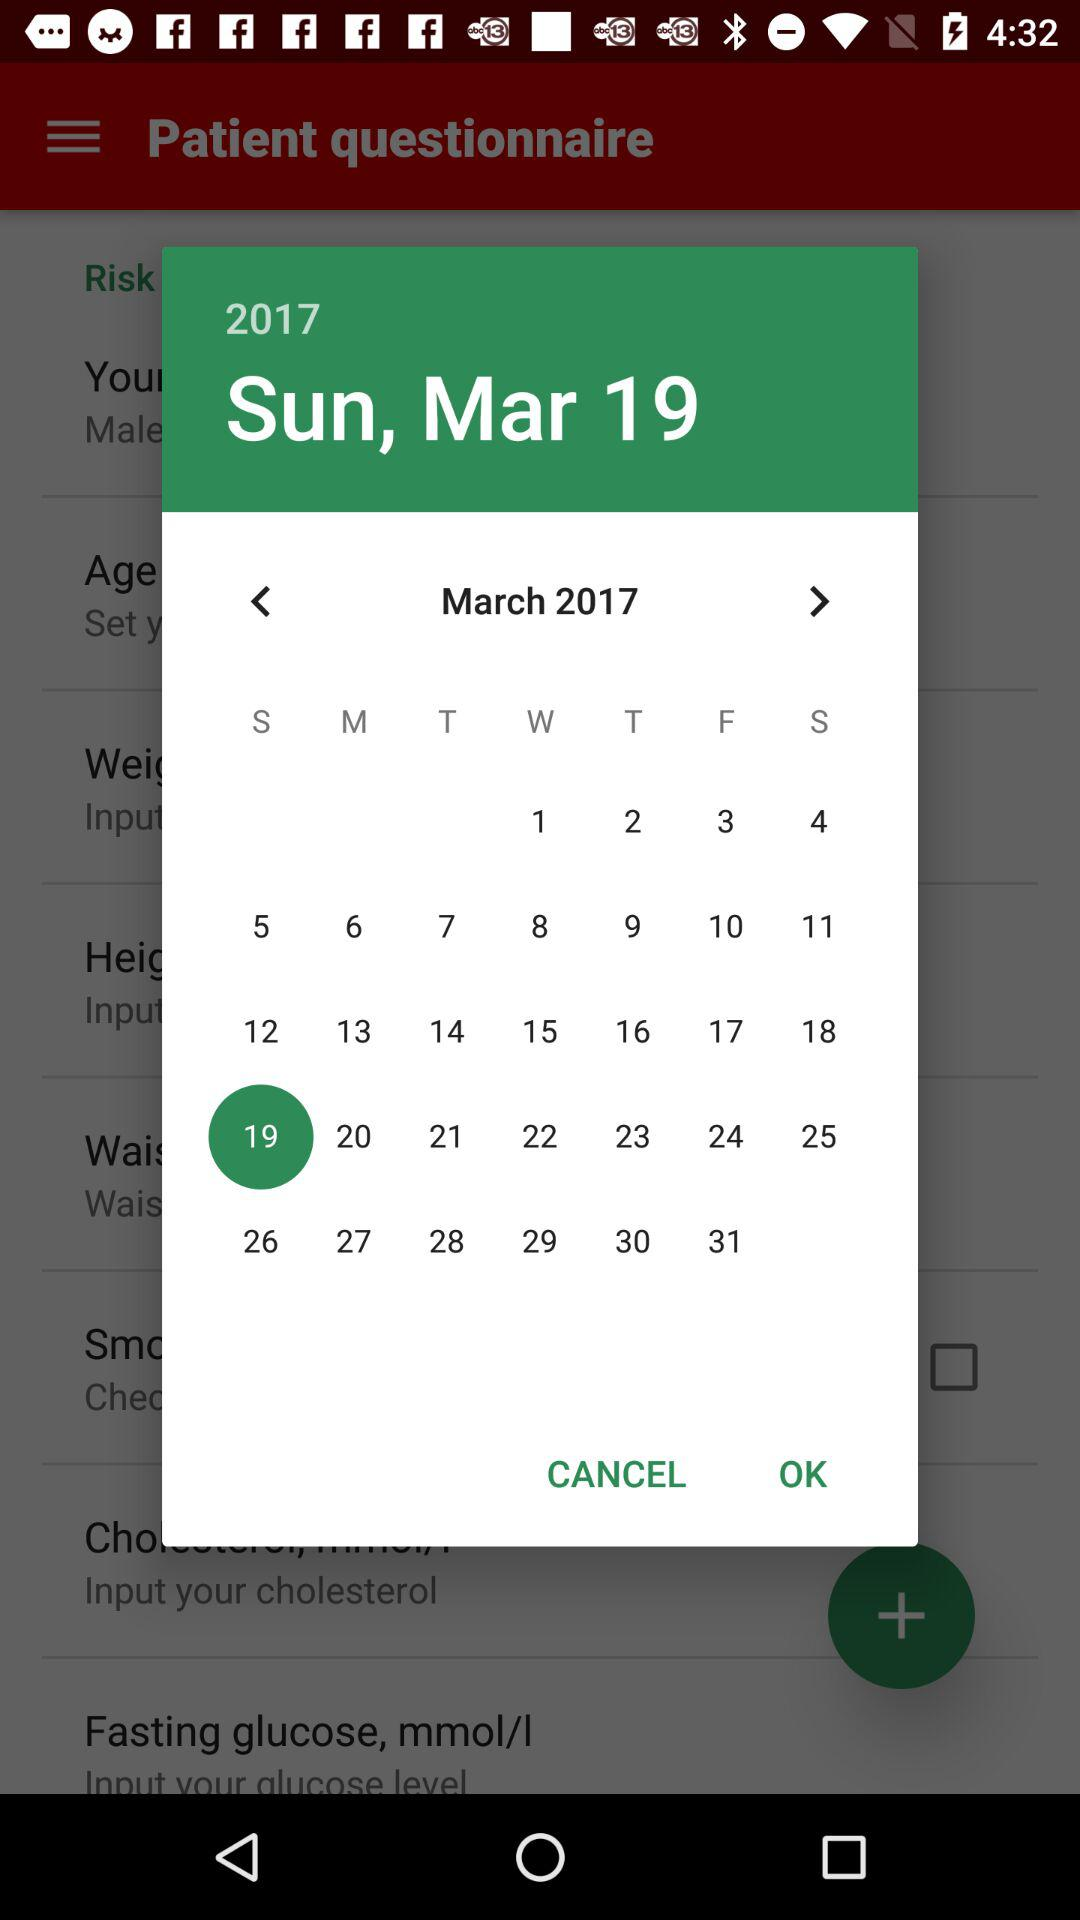Which day is March 17, 2017? The day is Friday. 